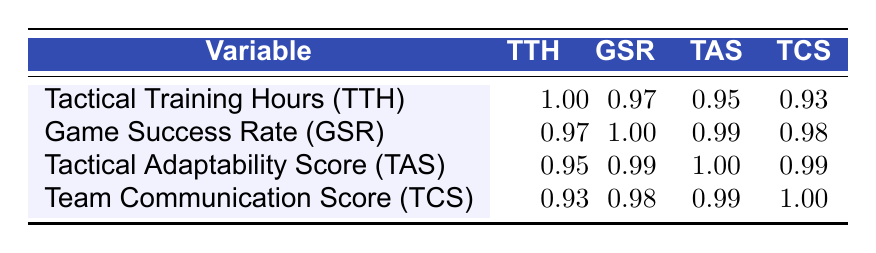What is the correlation between Tactical Training Hours and Game Success Rate? The table shows a correlation value of 0.97 between Tactical Training Hours (TTH) and Game Success Rate (GSR). This means that as the tactical training hours increase, the game success rate tends to increase as well.
Answer: 0.97 Is Tactical Adaptability Score correlated with Team Communication Score? Yes, the table indicates a correlation value of 0.99 between Tactical Adaptability Score (TAS) and Team Communication Score (TCS), suggesting a strong relationship between these two variables.
Answer: Yes What is the correlation between Game Success Rate and Tactical Adaptability Score? The correlation value between Game Success Rate (GSR) and Tactical Adaptability Score (TAS) is 0.99, indicating a very strong positive relationship; as one increases, the other tends to increase too.
Answer: 0.99 What is the average Tactical Training Hours for all players? To find the average, sum all Tactical Training Hours: 120 + 100 + 150 + 80 + 140 + 110 + 90 + 130 = 1,020. Then divide by the number of players (8): 1,020 / 8 = 127.5.
Answer: 127.5 Do players with higher Tactical Training Hours always have higher Game Success Rates? No, while there is a strong correlation (0.97), it does not mean that it is always the case. For example, Mason Brown has 80 Tactical Training Hours but a Game Success Rate of 55, while Liam Johnson has 100 hours but a rate of 65.
Answer: No What is the difference between the highest and lowest Game Success Rate among the players? The highest Game Success Rate is 85 (Noah Smith) and the lowest is 55 (Mason Brown). The difference is calculated as 85 - 55 = 30.
Answer: 30 Which player has the highest Tactical Adaptability Score? By looking at the Tactical Adaptability Score column, Noah Smith and Lucas Garcia both have the highest score of 9.
Answer: Noah Smith and Lucas Garcia Determine whether a Tactical Adaptability Score of 8 is associated with a Game Success Rate over 75. Yes, players like Ethan Ramirez and James Lewis, both of whom have a Tactical Adaptability Score of 8, have Game Success Rates of 75 and 78, respectively.
Answer: Yes 